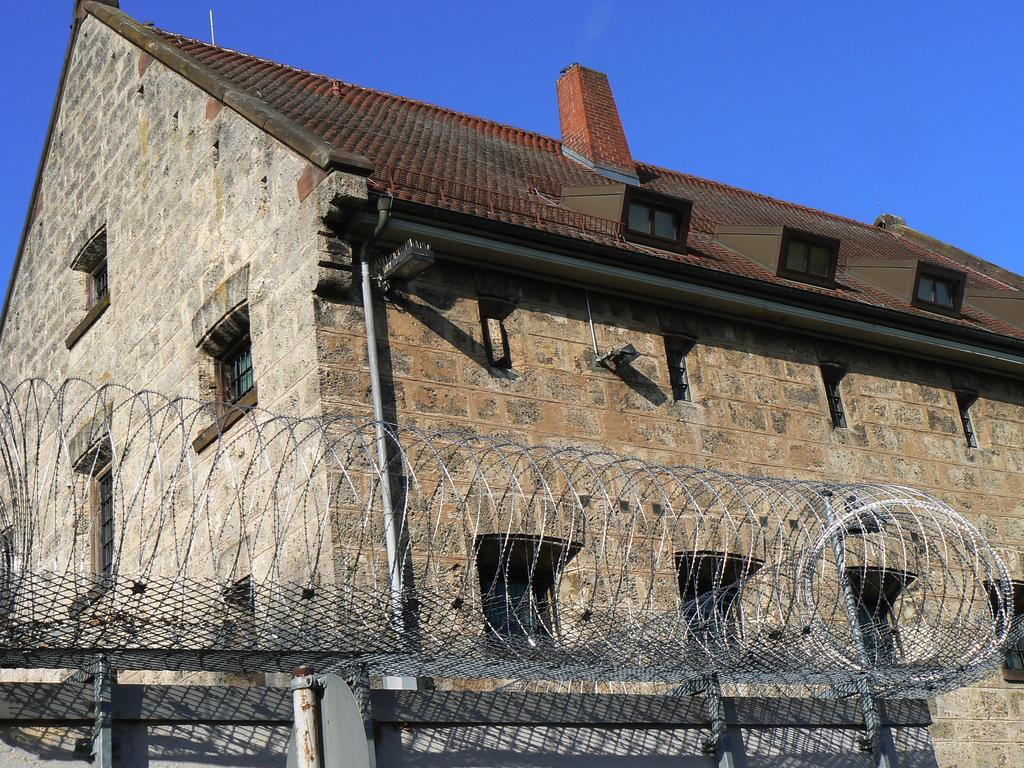What is the main structure in the image? There is a building in the center of the image. What is located at the bottom of the image? There is a fence at the bottom of the image. What can be seen in the background of the image? The sky is visible in the background of the image. What type of juice is being served at the building in the image? There is no mention of juice or any serving activity in the image; it only shows a building, a fence, and the sky. 